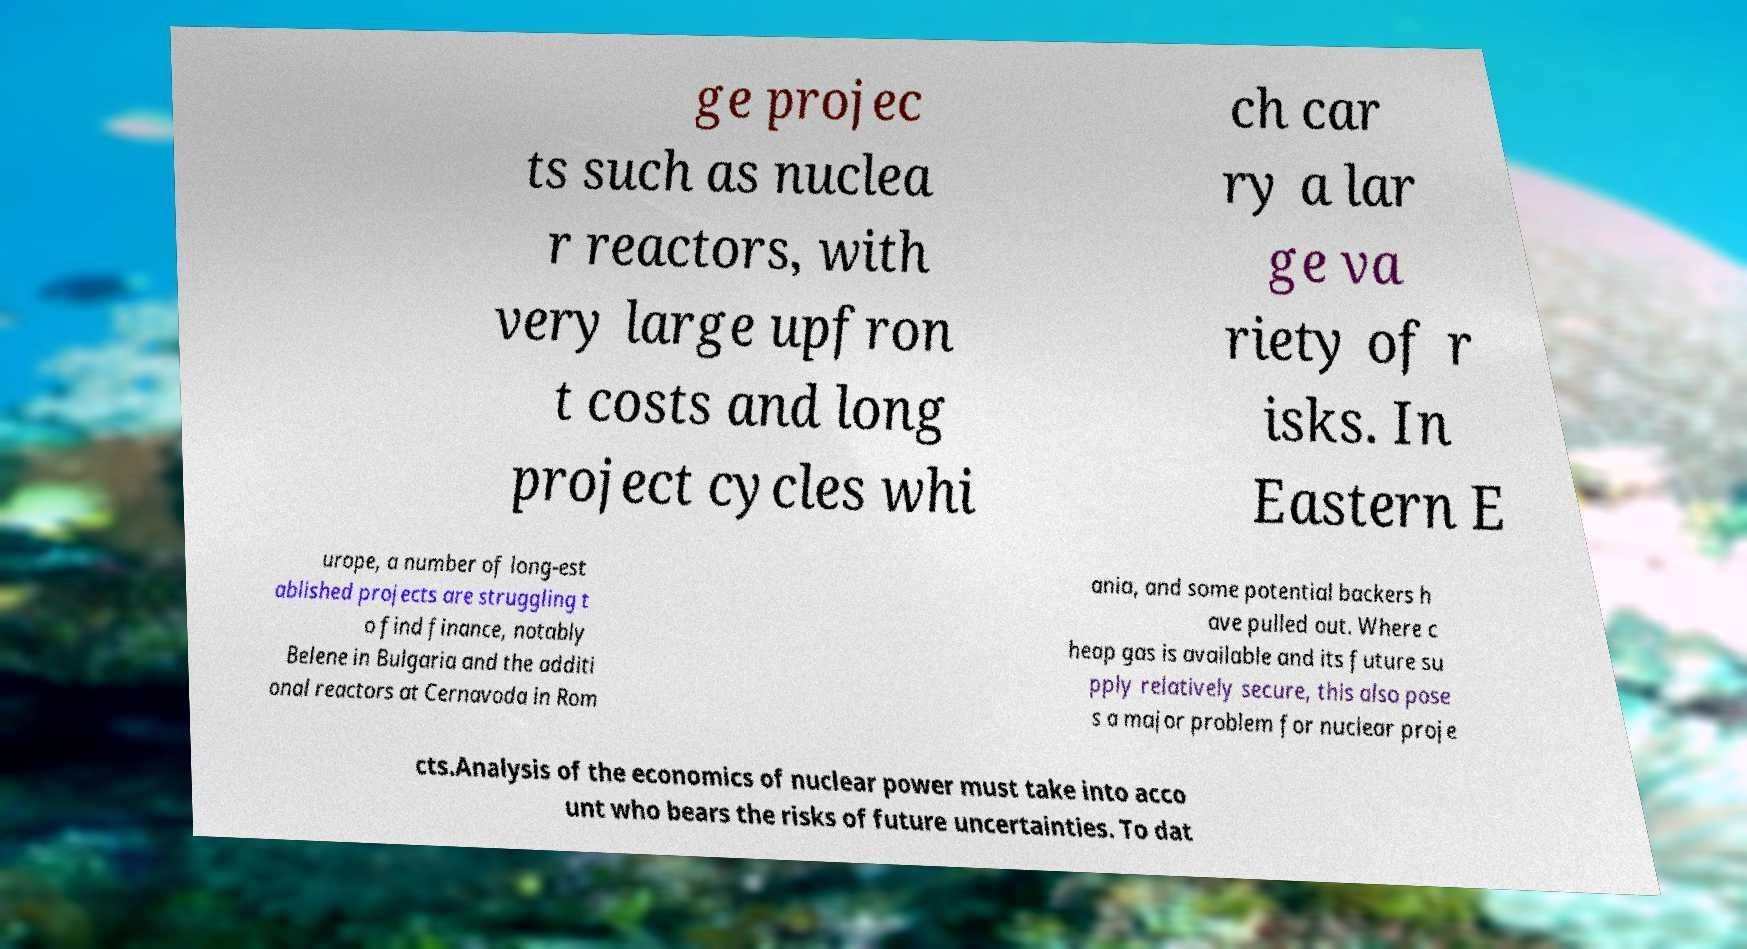Please read and relay the text visible in this image. What does it say? ge projec ts such as nuclea r reactors, with very large upfron t costs and long project cycles whi ch car ry a lar ge va riety of r isks. In Eastern E urope, a number of long-est ablished projects are struggling t o find finance, notably Belene in Bulgaria and the additi onal reactors at Cernavoda in Rom ania, and some potential backers h ave pulled out. Where c heap gas is available and its future su pply relatively secure, this also pose s a major problem for nuclear proje cts.Analysis of the economics of nuclear power must take into acco unt who bears the risks of future uncertainties. To dat 